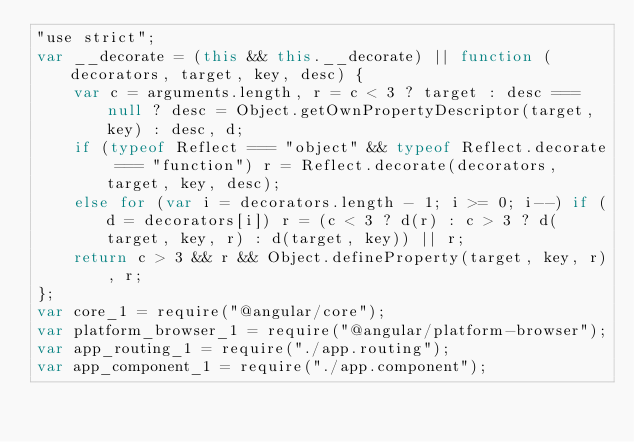<code> <loc_0><loc_0><loc_500><loc_500><_JavaScript_>"use strict";
var __decorate = (this && this.__decorate) || function (decorators, target, key, desc) {
    var c = arguments.length, r = c < 3 ? target : desc === null ? desc = Object.getOwnPropertyDescriptor(target, key) : desc, d;
    if (typeof Reflect === "object" && typeof Reflect.decorate === "function") r = Reflect.decorate(decorators, target, key, desc);
    else for (var i = decorators.length - 1; i >= 0; i--) if (d = decorators[i]) r = (c < 3 ? d(r) : c > 3 ? d(target, key, r) : d(target, key)) || r;
    return c > 3 && r && Object.defineProperty(target, key, r), r;
};
var core_1 = require("@angular/core");
var platform_browser_1 = require("@angular/platform-browser");
var app_routing_1 = require("./app.routing");
var app_component_1 = require("./app.component");</code> 